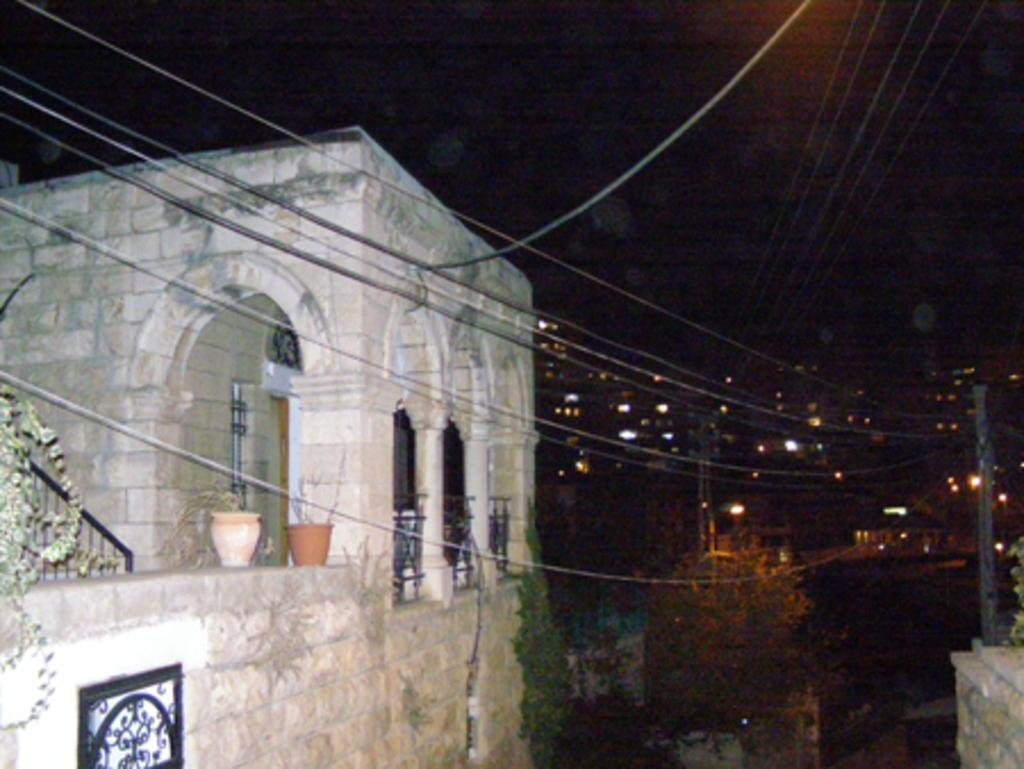What type of structures can be seen in the image? There are buildings in the image. What natural elements are present in the image? There are trees in the image. What man-made objects can be seen in the image? There are poles and wires in the image. Are there any plants visible on any of the structures in the image? Yes, there are plants on a building in the image. What type of cast can be seen on the basketball player's arm in the image? There is no basketball player or cast present in the image. What time of day is depicted in the image, considering the presence of night? The image does not depict a specific time of day, and there is no mention of night in the provided facts. 